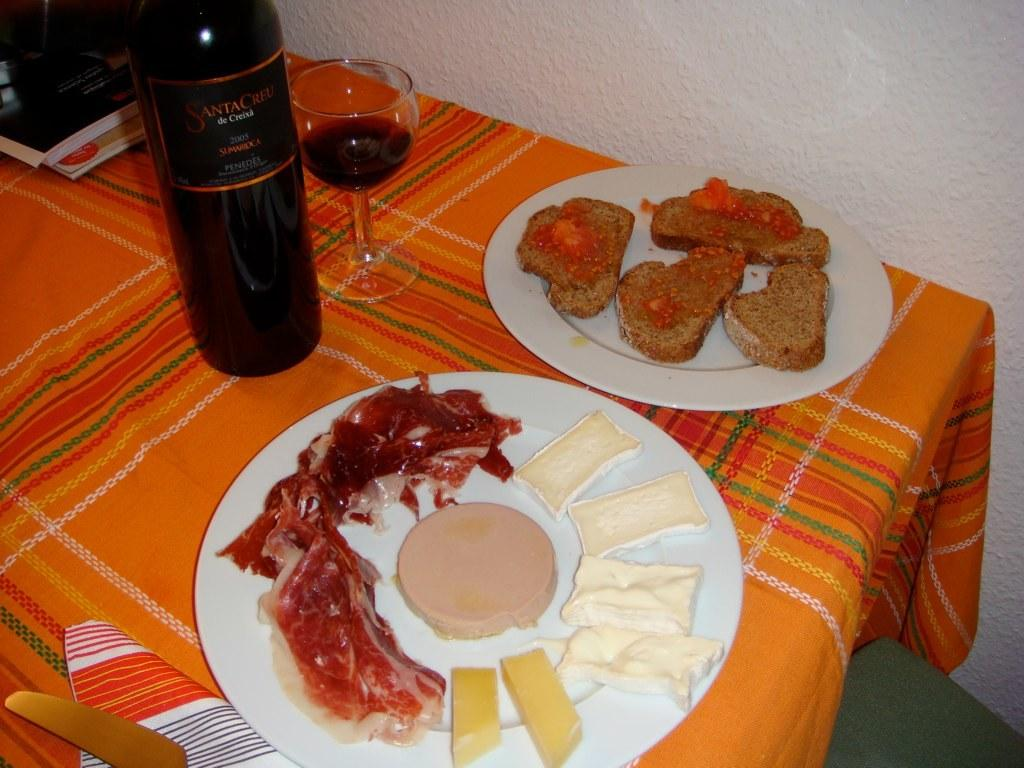Provide a one-sentence caption for the provided image. A bottle of 2003 red wine sits on a table next to some snacks. 